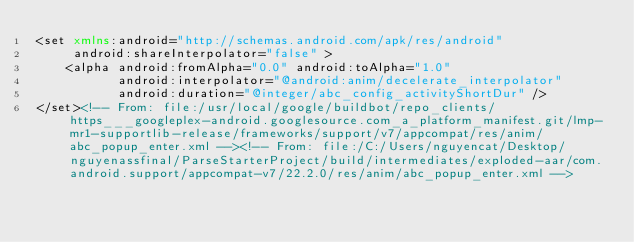Convert code to text. <code><loc_0><loc_0><loc_500><loc_500><_XML_><set xmlns:android="http://schemas.android.com/apk/res/android"
     android:shareInterpolator="false" >
    <alpha android:fromAlpha="0.0" android:toAlpha="1.0"
           android:interpolator="@android:anim/decelerate_interpolator"
           android:duration="@integer/abc_config_activityShortDur" />
</set><!-- From: file:/usr/local/google/buildbot/repo_clients/https___googleplex-android.googlesource.com_a_platform_manifest.git/lmp-mr1-supportlib-release/frameworks/support/v7/appcompat/res/anim/abc_popup_enter.xml --><!-- From: file:/C:/Users/nguyencat/Desktop/nguyenassfinal/ParseStarterProject/build/intermediates/exploded-aar/com.android.support/appcompat-v7/22.2.0/res/anim/abc_popup_enter.xml --></code> 